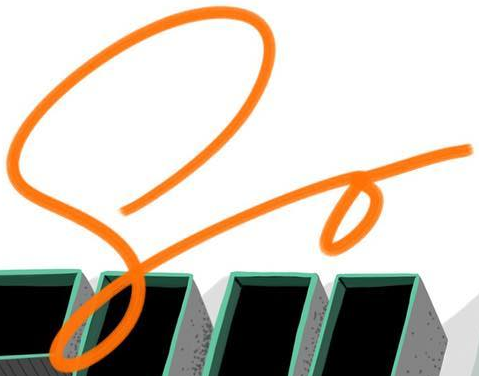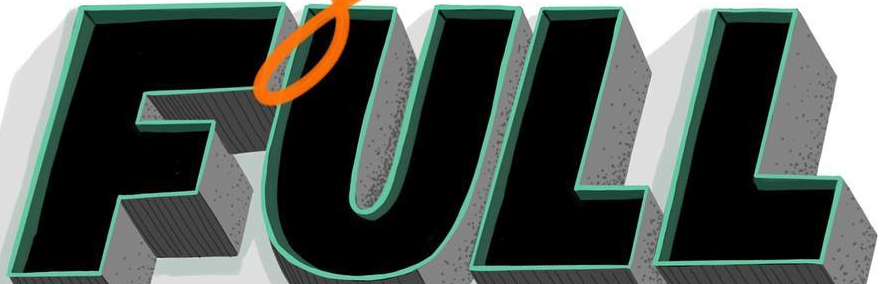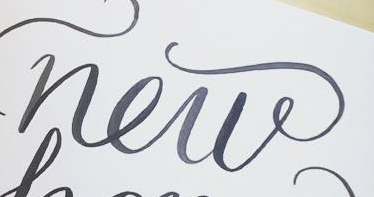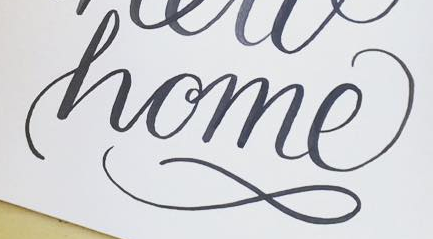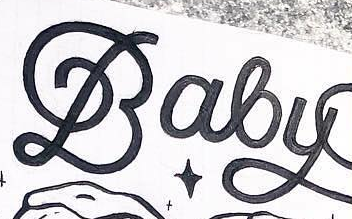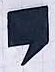What text is displayed in these images sequentially, separated by a semicolon? So; FULL; new; home; Baby; , 